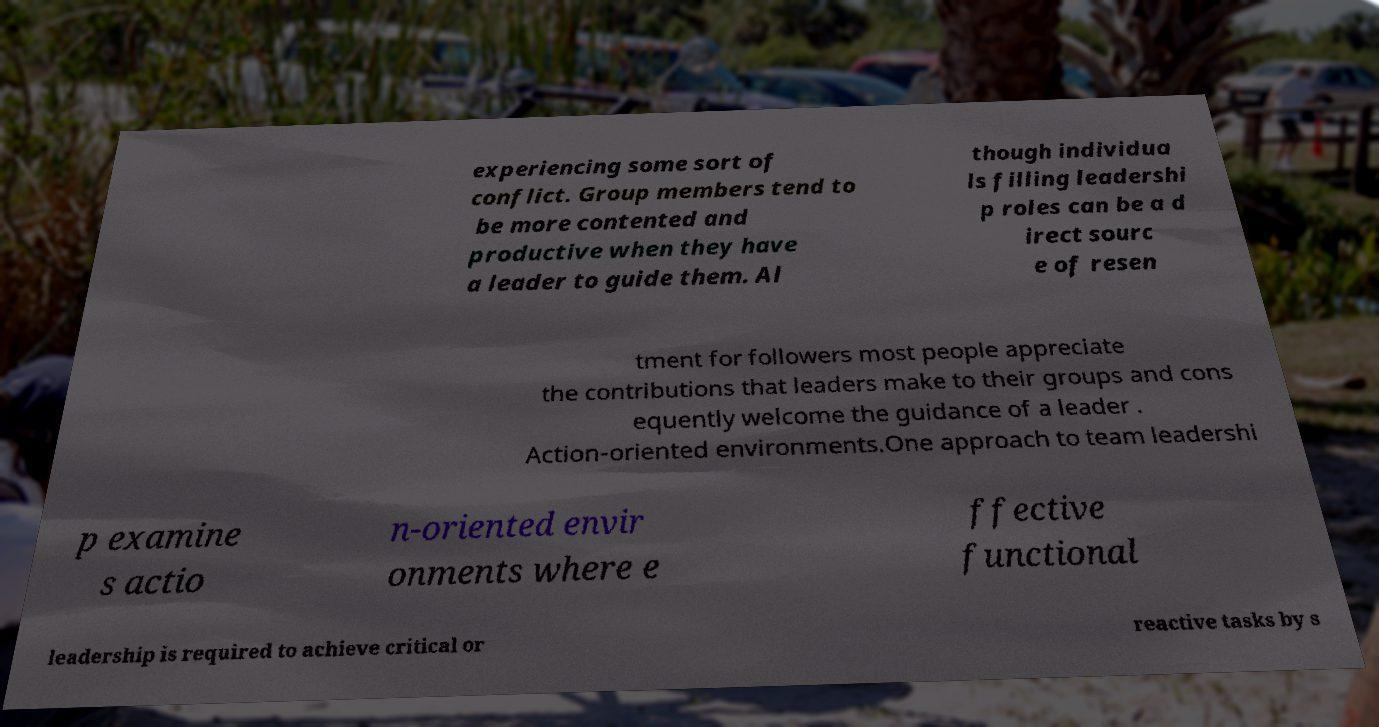I need the written content from this picture converted into text. Can you do that? experiencing some sort of conflict. Group members tend to be more contented and productive when they have a leader to guide them. Al though individua ls filling leadershi p roles can be a d irect sourc e of resen tment for followers most people appreciate the contributions that leaders make to their groups and cons equently welcome the guidance of a leader . Action-oriented environments.One approach to team leadershi p examine s actio n-oriented envir onments where e ffective functional leadership is required to achieve critical or reactive tasks by s 